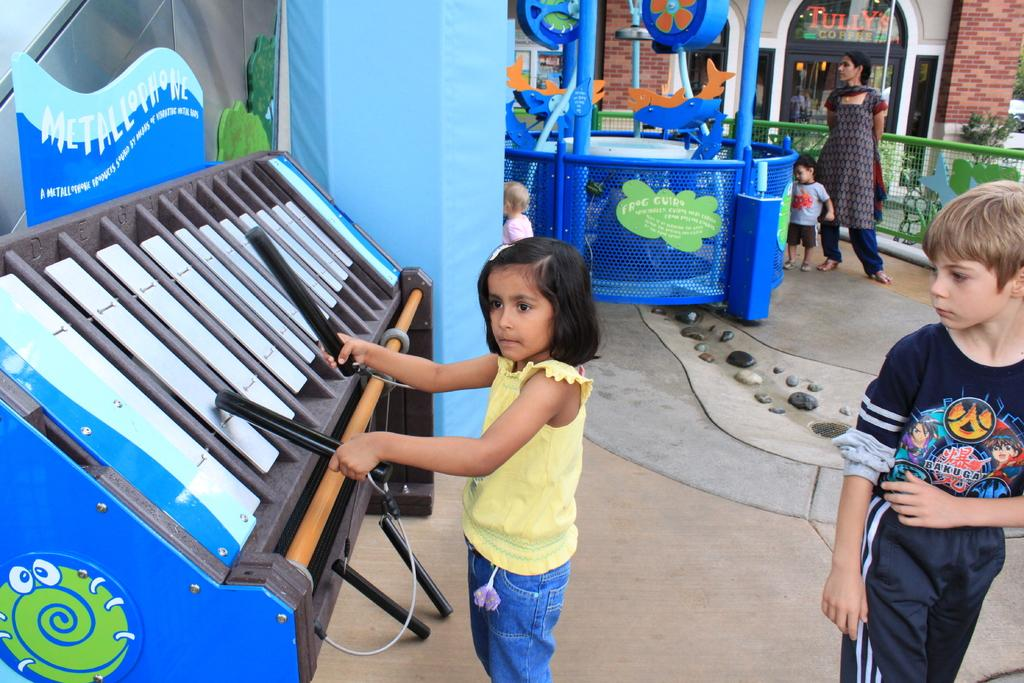What is the girl in the image doing? The girl is playing musical instruments in the image. What can be seen in the background of the image? There are other rides visible in the background, and people are standing there. What is the purpose of the fence in the image? The fence in the image may serve as a boundary or barrier. What type of structure is present in the image? There is a building in the image. What type of nerve is visible in the image? There is no nerve visible in the image; it features a girl playing musical instruments and other elements in the background. 